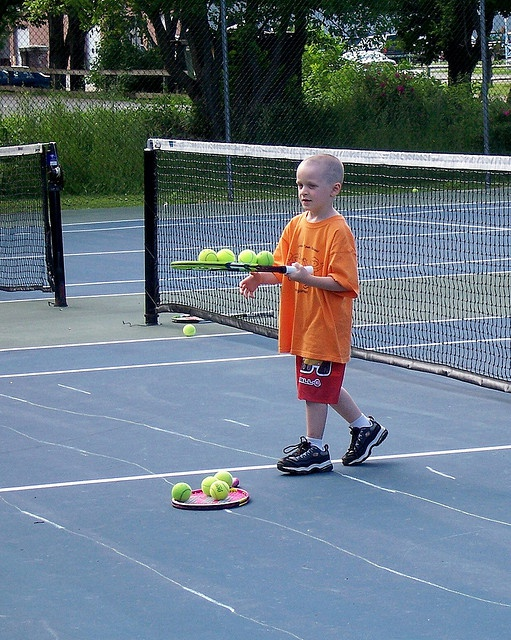Describe the objects in this image and their specific colors. I can see people in black, brown, gray, and red tones, tennis racket in black, lavender, lightpink, and darkgray tones, tennis racket in black, green, darkgreen, and teal tones, sports ball in black, olive, khaki, lightgreen, and lightyellow tones, and sports ball in black, green, lightgreen, khaki, and beige tones in this image. 